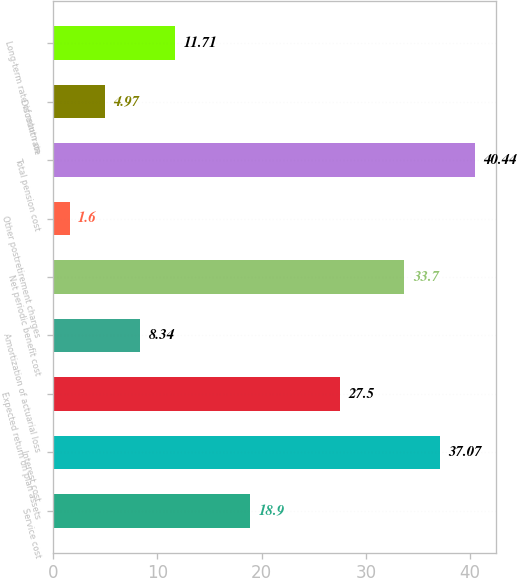<chart> <loc_0><loc_0><loc_500><loc_500><bar_chart><fcel>Service cost<fcel>Interest cost<fcel>Expected return on plan assets<fcel>Amortization of actuarial loss<fcel>Net periodic benefit cost<fcel>Other postretirement charges<fcel>Total pension cost<fcel>Discount rate<fcel>Long-term rate of return on<nl><fcel>18.9<fcel>37.07<fcel>27.5<fcel>8.34<fcel>33.7<fcel>1.6<fcel>40.44<fcel>4.97<fcel>11.71<nl></chart> 